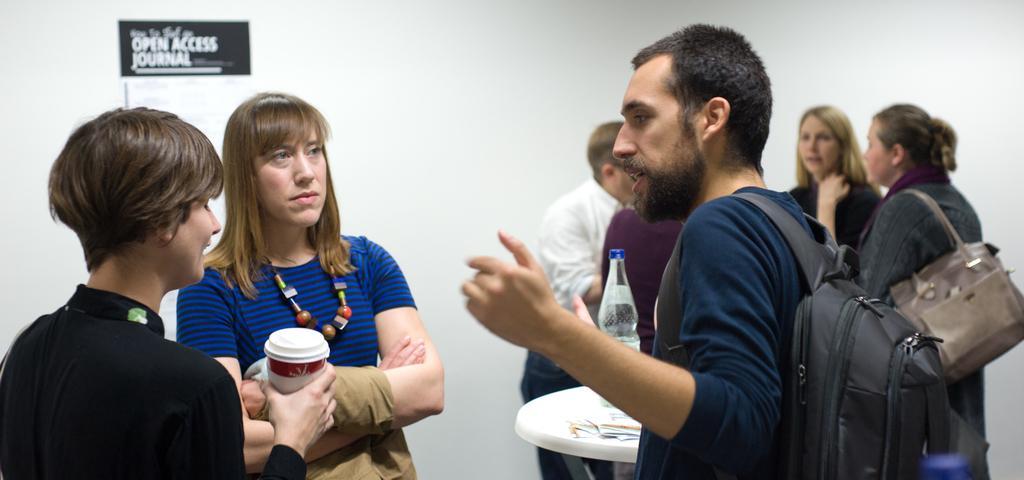Could you give a brief overview of what you see in this image? In this picture we can see a person wearing a bag on the right side. We can see a woman holding a cup and another woman is visible on the left side. There is a bottle and a few pages visible on a table. We can see a few people at the back. There is some text visible on a black surface. Background is white in color. 